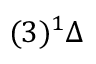Convert formula to latex. <formula><loc_0><loc_0><loc_500><loc_500>( 3 ) ^ { 1 } \Delta</formula> 